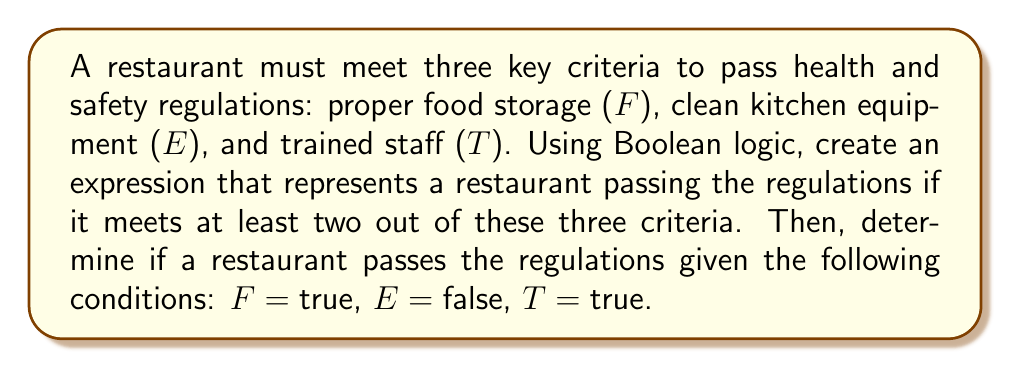Can you answer this question? Let's approach this step-by-step:

1) First, we need to create a Boolean expression that represents passing the regulations. We want at least two out of three criteria to be true. We can express this using the following Boolean formula:

   $$(F \wedge E) \vee (F \wedge T) \vee (E \wedge T)$$

   Where $\wedge$ represents AND, and $\vee$ represents OR.

2) Now, let's substitute the given values:
   F = true
   E = false
   T = true

3) Let's evaluate each part of the expression:

   $(F \wedge E)$ = (true $\wedge$ false) = false
   $(F \wedge T)$ = (true $\wedge$ true) = true
   $(E \wedge T)$ = (false $\wedge$ true) = false

4) Now our expression looks like this:

   false $\vee$ true $\vee$ false

5) In Boolean logic, true $\vee$ anything is always true. Therefore, the final result is true.

Thus, the restaurant passes the health and safety regulations because it meets at least two out of the three criteria (proper food storage and trained staff).
Answer: true 